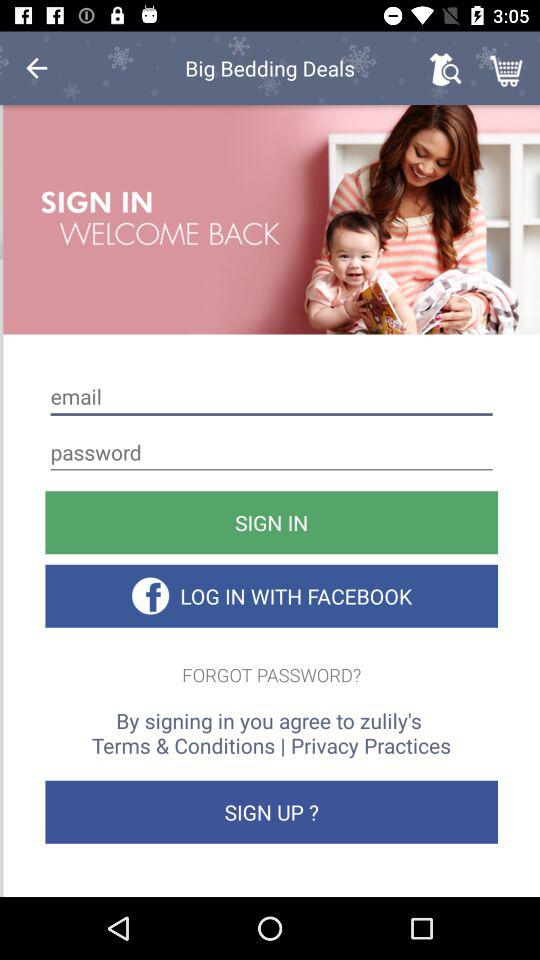How many input fields are there for signing in?
Answer the question using a single word or phrase. 2 